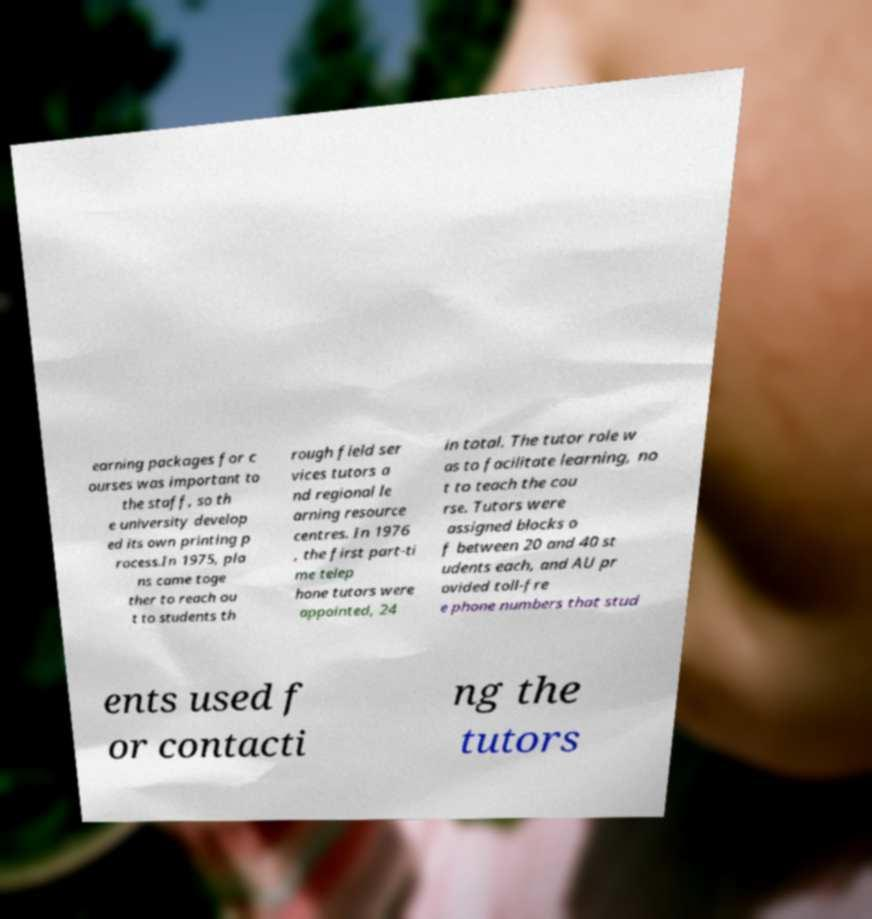Can you accurately transcribe the text from the provided image for me? earning packages for c ourses was important to the staff, so th e university develop ed its own printing p rocess.In 1975, pla ns came toge ther to reach ou t to students th rough field ser vices tutors a nd regional le arning resource centres. In 1976 , the first part-ti me telep hone tutors were appointed, 24 in total. The tutor role w as to facilitate learning, no t to teach the cou rse. Tutors were assigned blocks o f between 20 and 40 st udents each, and AU pr ovided toll-fre e phone numbers that stud ents used f or contacti ng the tutors 